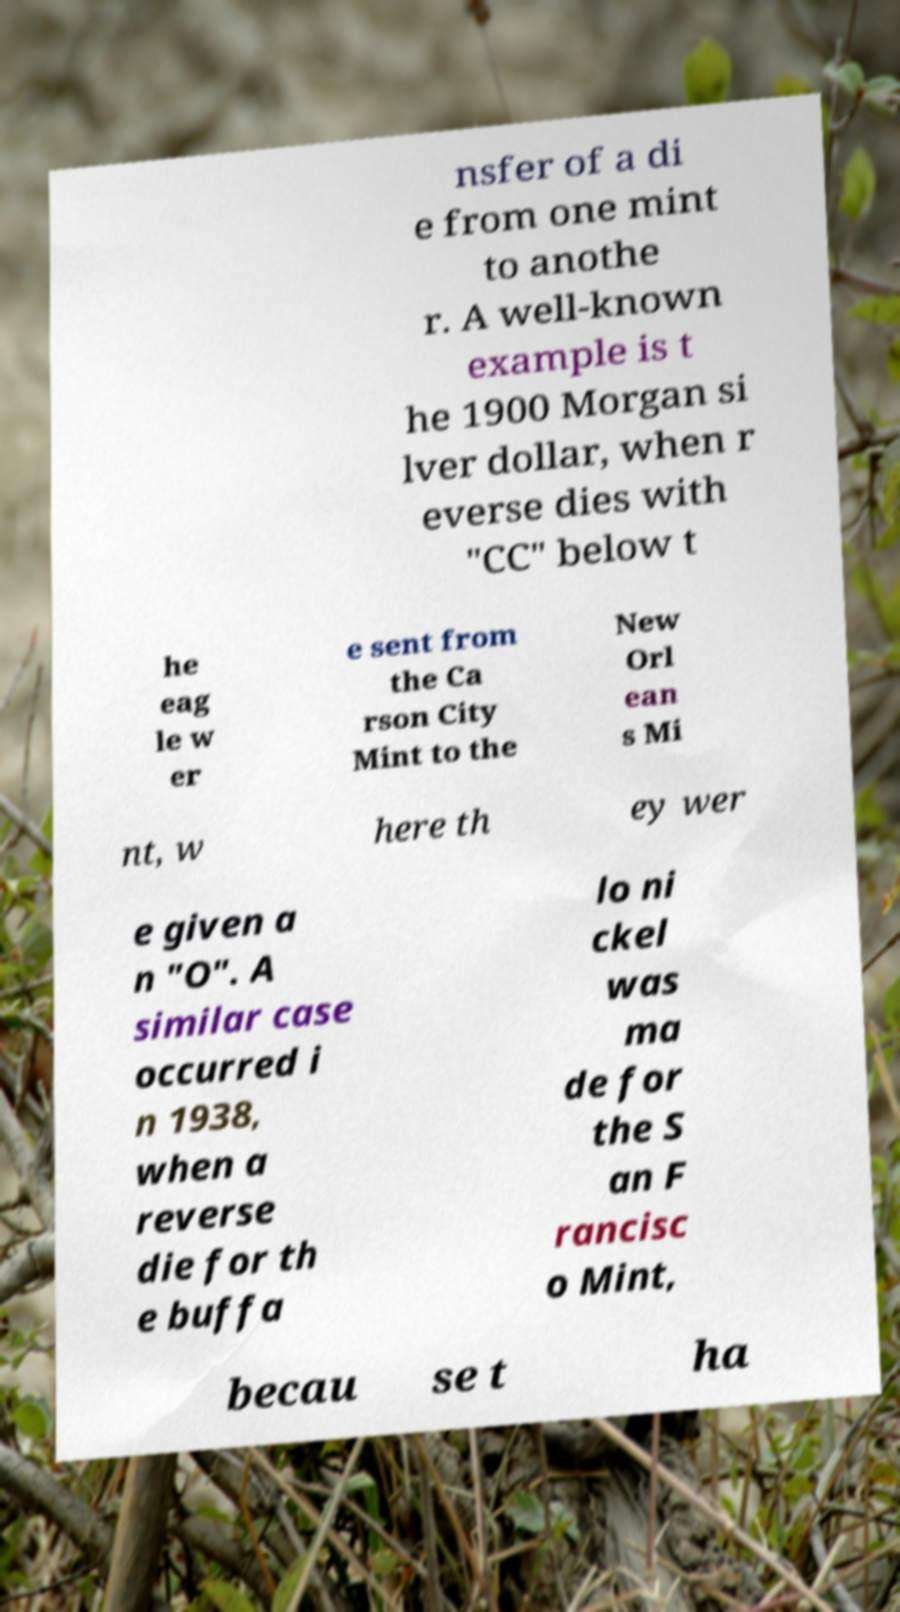I need the written content from this picture converted into text. Can you do that? nsfer of a di e from one mint to anothe r. A well-known example is t he 1900 Morgan si lver dollar, when r everse dies with "CC" below t he eag le w er e sent from the Ca rson City Mint to the New Orl ean s Mi nt, w here th ey wer e given a n "O". A similar case occurred i n 1938, when a reverse die for th e buffa lo ni ckel was ma de for the S an F rancisc o Mint, becau se t ha 